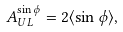Convert formula to latex. <formula><loc_0><loc_0><loc_500><loc_500>A ^ { \sin \phi } _ { U L } = 2 \langle \sin \phi \rangle ,</formula> 